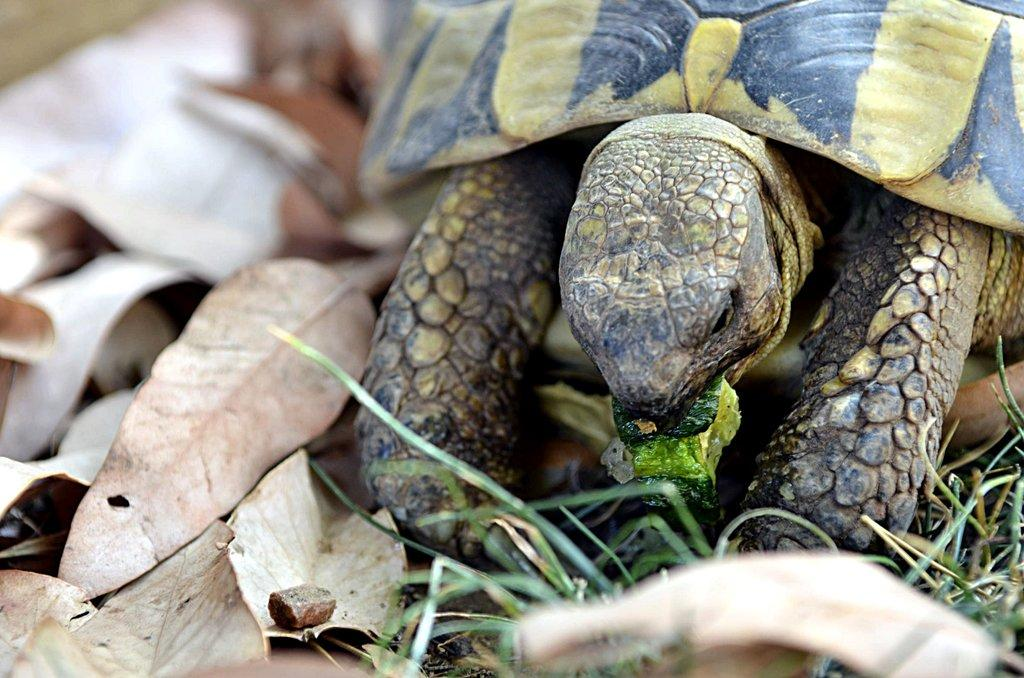What type of animal is in the image? There is a tortoise in the image. What type of vegetation is present in the image? There is grass and leaves in the image. What type of cracker is being used to feed the tortoise in the image? There is no cracker present in the image, and the tortoise is not being fed. 